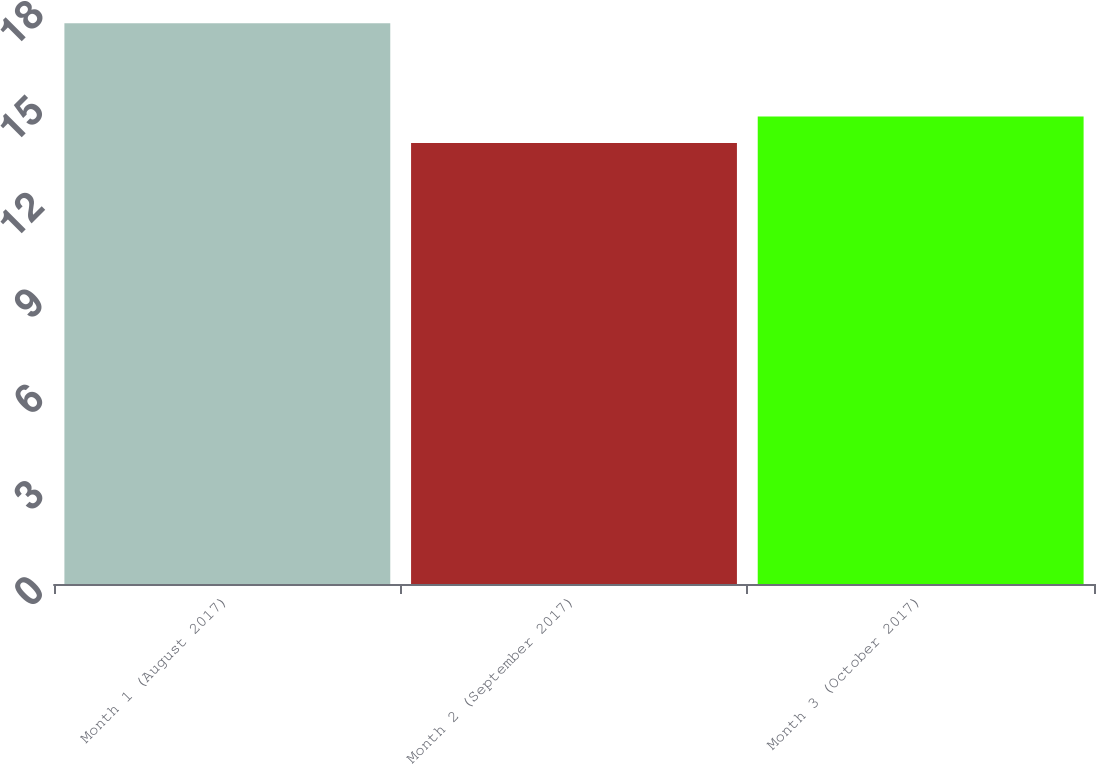Convert chart. <chart><loc_0><loc_0><loc_500><loc_500><bar_chart><fcel>Month 1 (August 2017)<fcel>Month 2 (September 2017)<fcel>Month 3 (October 2017)<nl><fcel>17.52<fcel>13.78<fcel>14.61<nl></chart> 